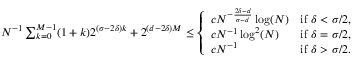Convert formula to latex. <formula><loc_0><loc_0><loc_500><loc_500>\begin{array} { r } { N ^ { - 1 } \sum _ { k = 0 } ^ { M - 1 } ( 1 + k ) 2 ^ { ( \sigma - 2 \delta ) k } + 2 ^ { ( d - 2 \delta ) M } \leq \left \{ \begin{array} { l l } { c N ^ { - \frac { 2 \delta - d } { \sigma - d } } \log ( N ) } & { i f \delta < \sigma / 2 , } \\ { c N ^ { - 1 } \log ^ { 2 } ( N ) } & { i f \delta = \sigma / 2 , } \\ { c N ^ { - 1 } } & { i f \delta > \sigma / 2 . } \end{array} } \end{array}</formula> 